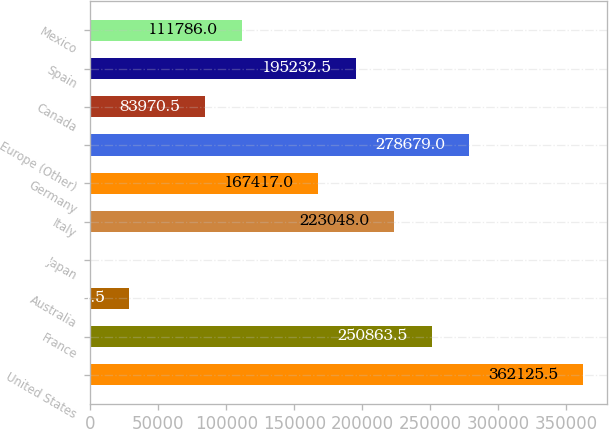Convert chart to OTSL. <chart><loc_0><loc_0><loc_500><loc_500><bar_chart><fcel>United States<fcel>France<fcel>Australia<fcel>Japan<fcel>Italy<fcel>Germany<fcel>Europe (Other)<fcel>Canada<fcel>Spain<fcel>Mexico<nl><fcel>362126<fcel>250864<fcel>28339.5<fcel>524<fcel>223048<fcel>167417<fcel>278679<fcel>83970.5<fcel>195232<fcel>111786<nl></chart> 